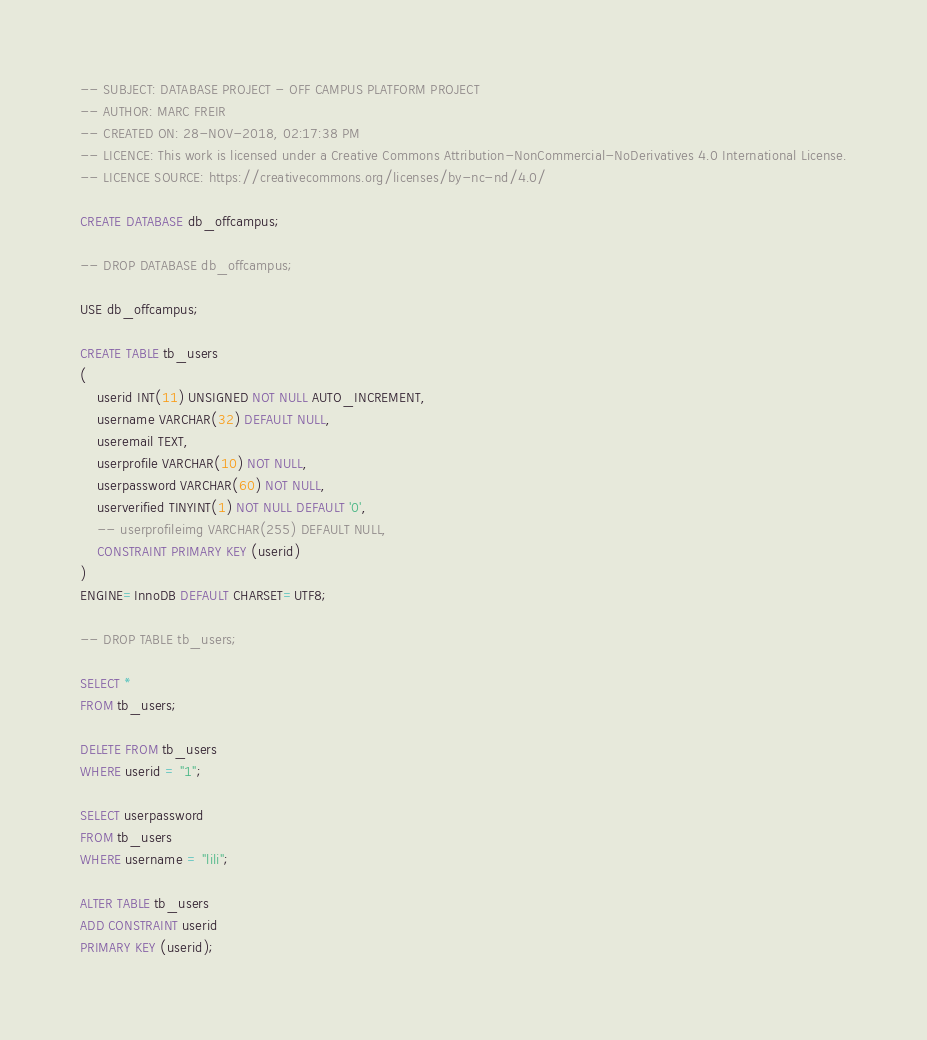Convert code to text. <code><loc_0><loc_0><loc_500><loc_500><_SQL_>-- SUBJECT: DATABASE PROJECT - OFF CAMPUS PLATFORM PROJECT
-- AUTHOR: MARC FREIR
-- CREATED ON: 28-NOV-2018, 02:17:38 PM
-- LICENCE: This work is licensed under a Creative Commons Attribution-NonCommercial-NoDerivatives 4.0 International License.
-- LICENCE SOURCE: https://creativecommons.org/licenses/by-nc-nd/4.0/

CREATE DATABASE db_offcampus;

-- DROP DATABASE db_offcampus;

USE db_offcampus;

CREATE TABLE tb_users
(
	userid INT(11) UNSIGNED NOT NULL AUTO_INCREMENT,
	username VARCHAR(32) DEFAULT NULL,
	useremail TEXT,
	userprofile VARCHAR(10) NOT NULL,
	userpassword VARCHAR(60) NOT NULL,
	userverified TINYINT(1) NOT NULL DEFAULT '0',
	-- userprofileimg VARCHAR(255) DEFAULT NULL,
	CONSTRAINT PRIMARY KEY (userid)
)
ENGINE=InnoDB DEFAULT CHARSET=UTF8;

-- DROP TABLE tb_users;

SELECT *
FROM tb_users;

DELETE FROM tb_users
WHERE userid = "1";

SELECT userpassword
FROM tb_users
WHERE username = "lili";

ALTER TABLE tb_users
ADD CONSTRAINT userid
PRIMARY KEY (userid);
</code> 